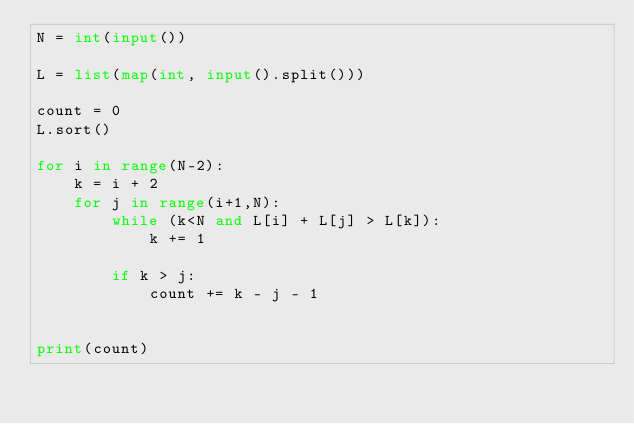<code> <loc_0><loc_0><loc_500><loc_500><_Python_>N = int(input())

L = list(map(int, input().split()))

count = 0 
L.sort()

for i in range(N-2):
    k = i + 2
    for j in range(i+1,N):
        while (k<N and L[i] + L[j] > L[k]):
            k += 1

        if k > j:
            count += k - j - 1


print(count)

</code> 